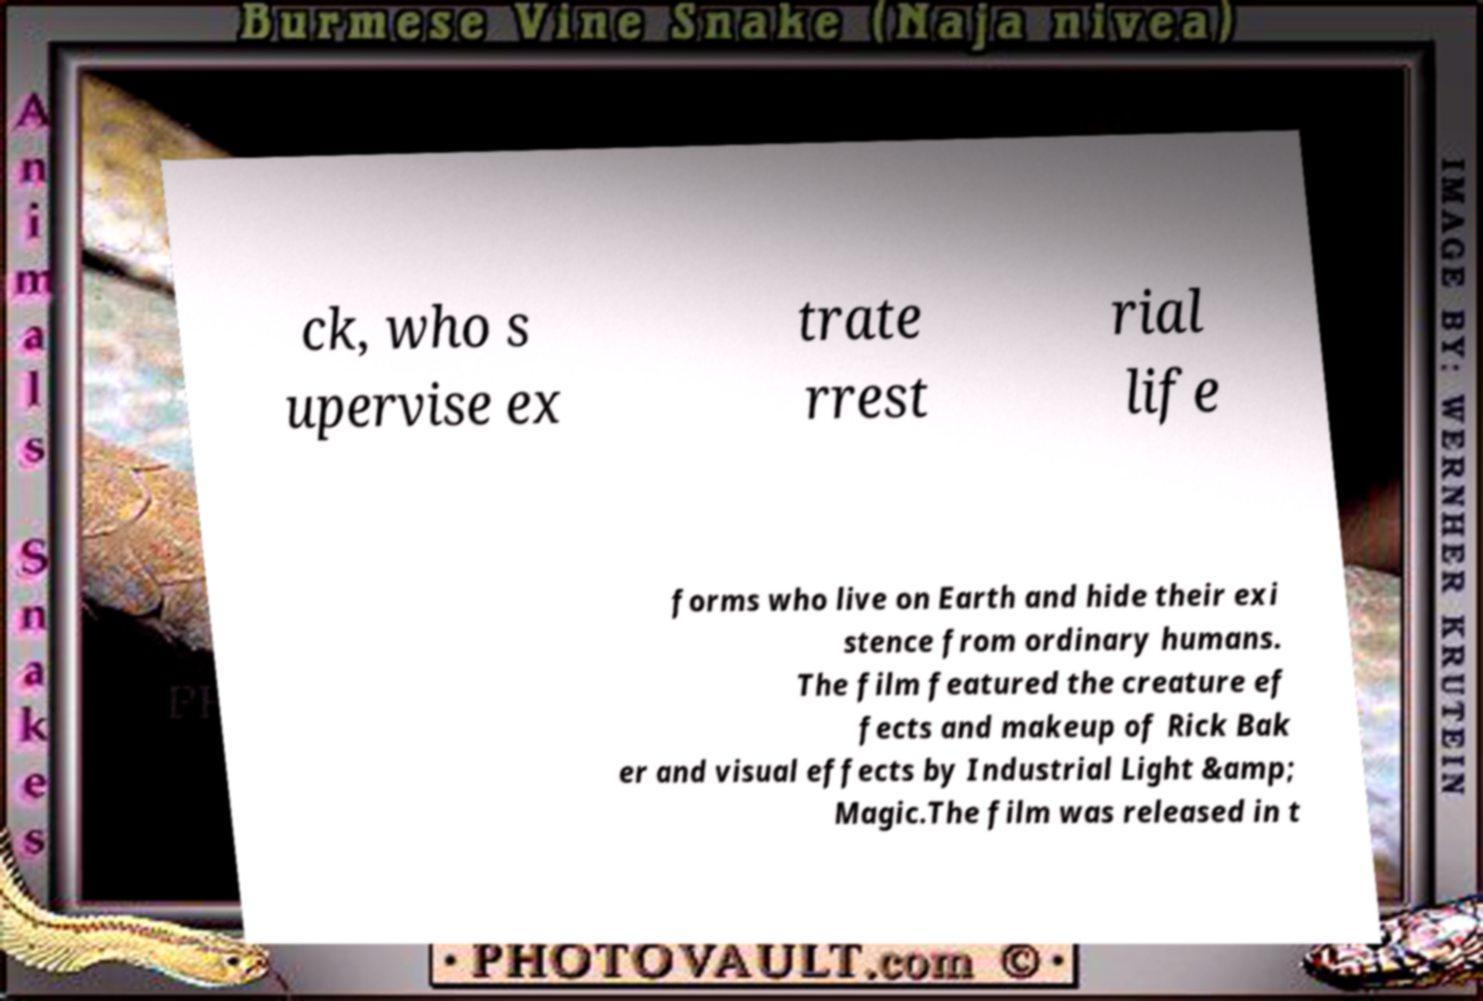For documentation purposes, I need the text within this image transcribed. Could you provide that? ck, who s upervise ex trate rrest rial life forms who live on Earth and hide their exi stence from ordinary humans. The film featured the creature ef fects and makeup of Rick Bak er and visual effects by Industrial Light &amp; Magic.The film was released in t 